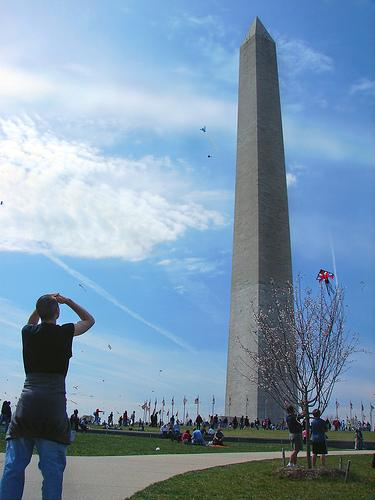What kind of people visit this place throughout the year? Please explain your reasoning. tourists. Many people travel here to look at this sculpture. 